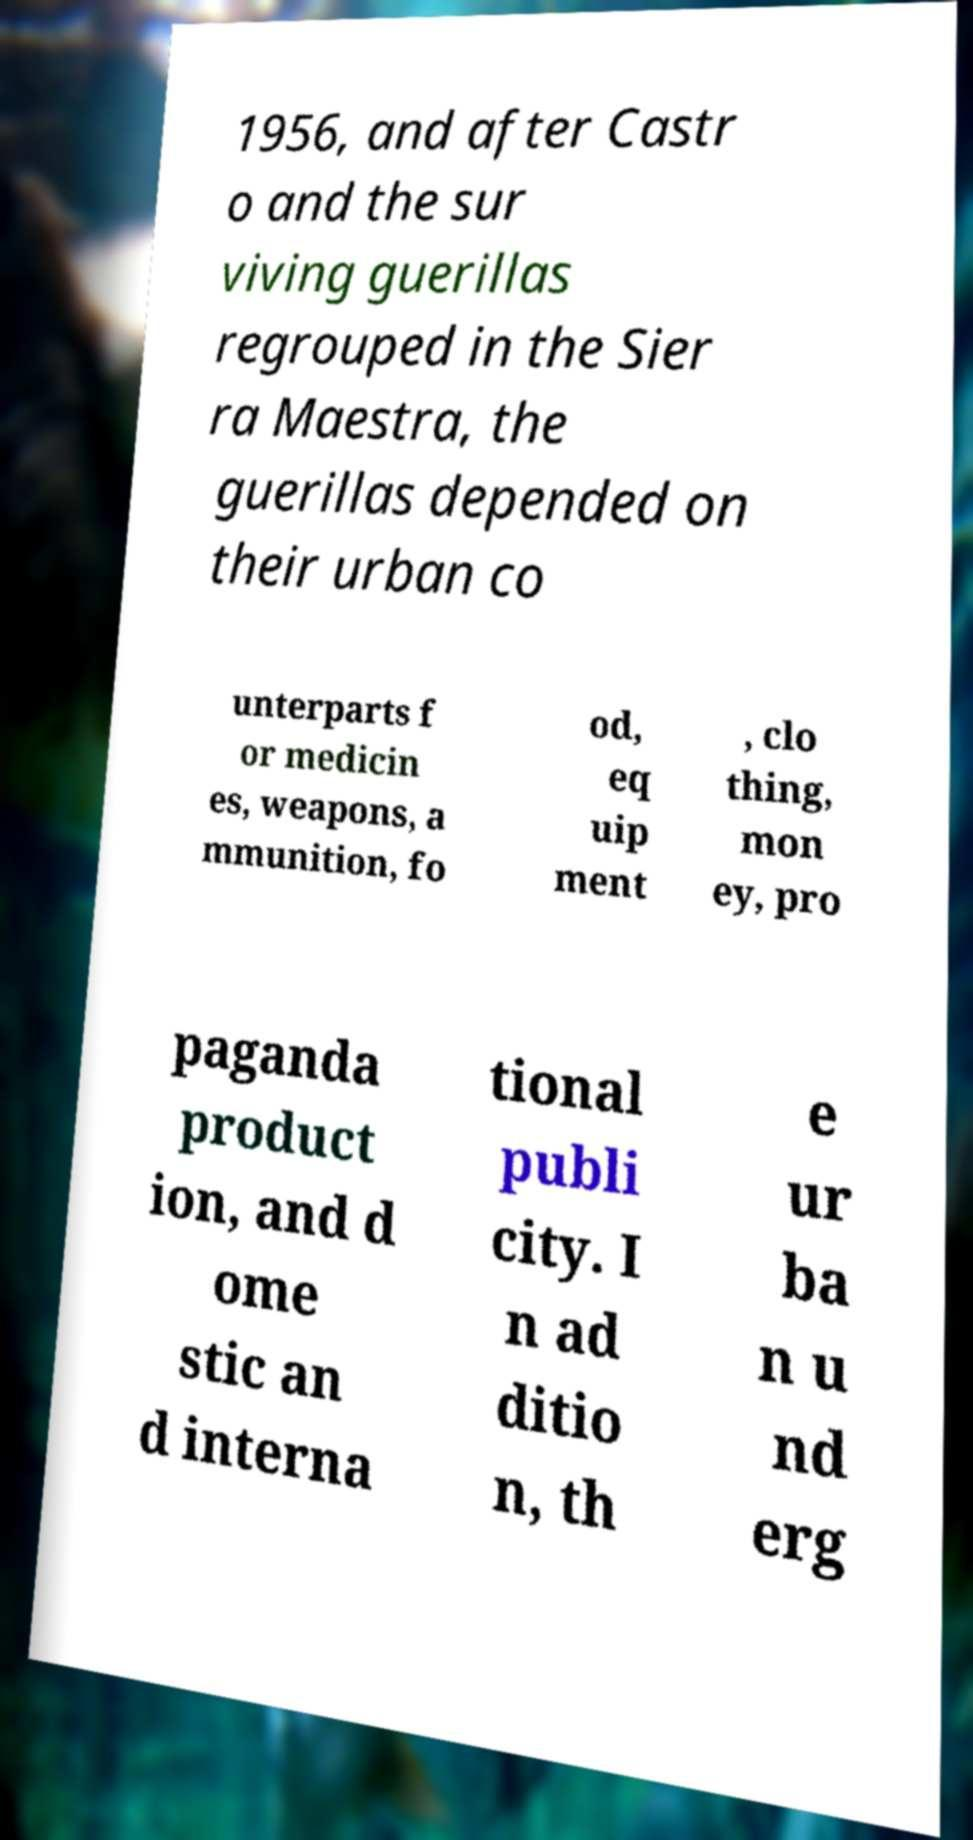Could you extract and type out the text from this image? 1956, and after Castr o and the sur viving guerillas regrouped in the Sier ra Maestra, the guerillas depended on their urban co unterparts f or medicin es, weapons, a mmunition, fo od, eq uip ment , clo thing, mon ey, pro paganda product ion, and d ome stic an d interna tional publi city. I n ad ditio n, th e ur ba n u nd erg 